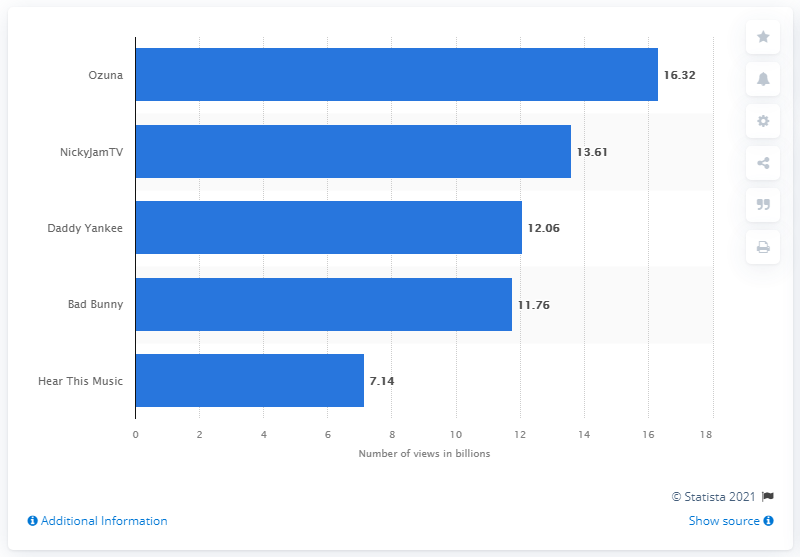Identify some key points in this picture. The first YouTube subscriber in Puerto Rico is Daddy Yankee. According to data from YouTube channels in Puerto Rico, Bad Bunnay has had approximately 11.76 billion video views. NickyJamTV is the second most viewed YouTube channel in Puerto Rico, coming in behind only another channel. Ozuna's YouTube videos have had a total of 16,320 views. 